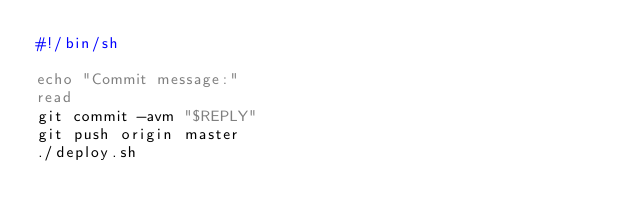<code> <loc_0><loc_0><loc_500><loc_500><_Bash_>#!/bin/sh

echo "Commit message:"
read
git commit -avm "$REPLY"
git push origin master
./deploy.sh
</code> 